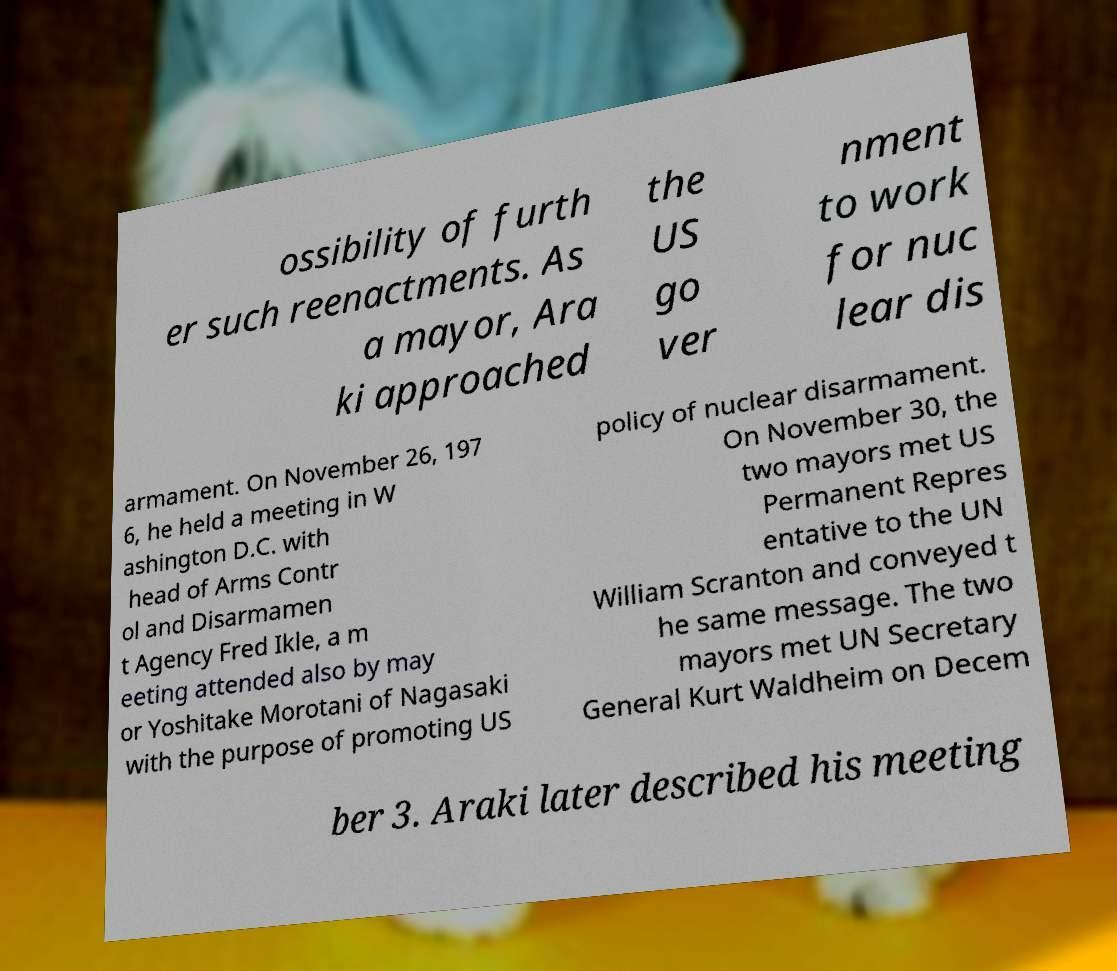Can you read and provide the text displayed in the image?This photo seems to have some interesting text. Can you extract and type it out for me? ossibility of furth er such reenactments. As a mayor, Ara ki approached the US go ver nment to work for nuc lear dis armament. On November 26, 197 6, he held a meeting in W ashington D.C. with head of Arms Contr ol and Disarmamen t Agency Fred Ikle, a m eeting attended also by may or Yoshitake Morotani of Nagasaki with the purpose of promoting US policy of nuclear disarmament. On November 30, the two mayors met US Permanent Repres entative to the UN William Scranton and conveyed t he same message. The two mayors met UN Secretary General Kurt Waldheim on Decem ber 3. Araki later described his meeting 